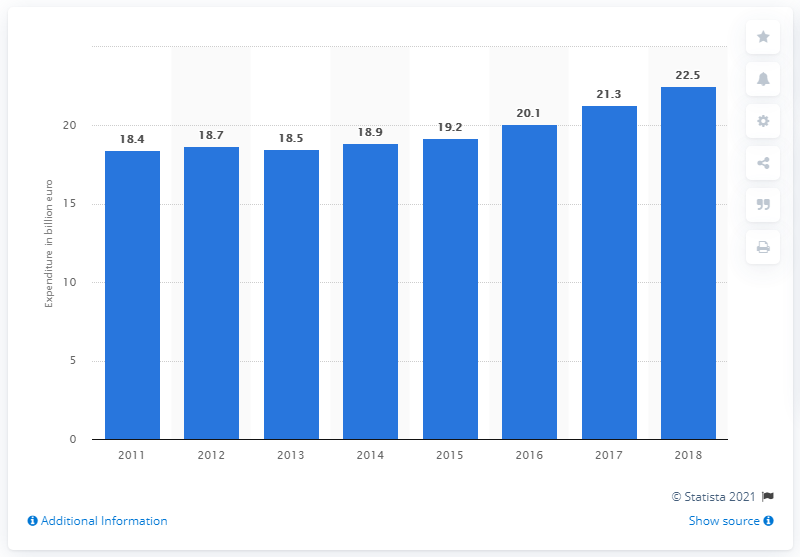Give some essential details in this illustration. In 2011, Ireland's expenditure on health was 18.5%. In 2018, Ireland's health expenditure was 22.5%. 